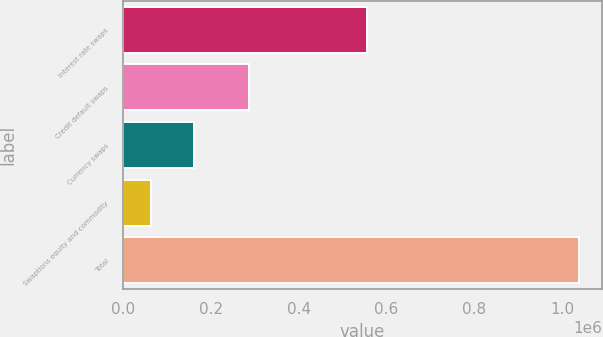Convert chart. <chart><loc_0><loc_0><loc_500><loc_500><bar_chart><fcel>Interest rate swaps<fcel>Credit default swaps<fcel>Currency swaps<fcel>Swaptions equity and commodity<fcel>Total<nl><fcel>554917<fcel>286069<fcel>160466<fcel>62849<fcel>1.03902e+06<nl></chart> 